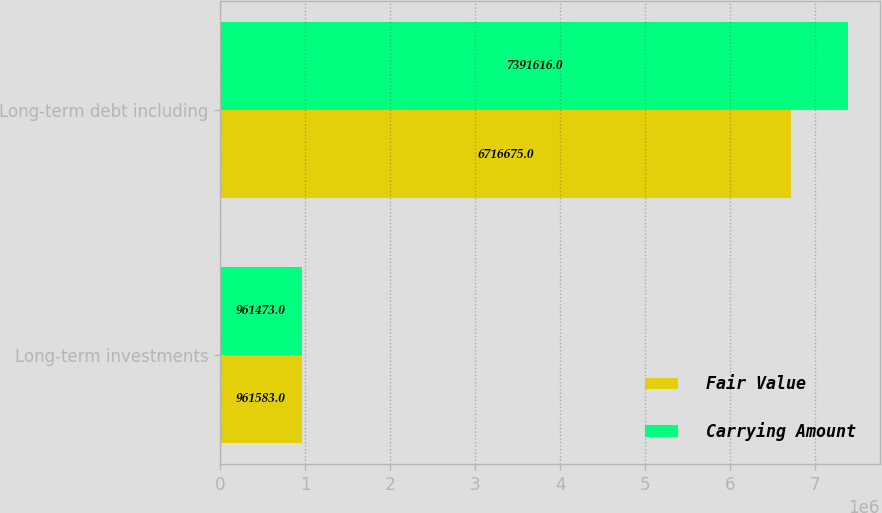Convert chart. <chart><loc_0><loc_0><loc_500><loc_500><stacked_bar_chart><ecel><fcel>Long-term investments<fcel>Long-term debt including<nl><fcel>Fair Value<fcel>961583<fcel>6.71668e+06<nl><fcel>Carrying Amount<fcel>961473<fcel>7.39162e+06<nl></chart> 